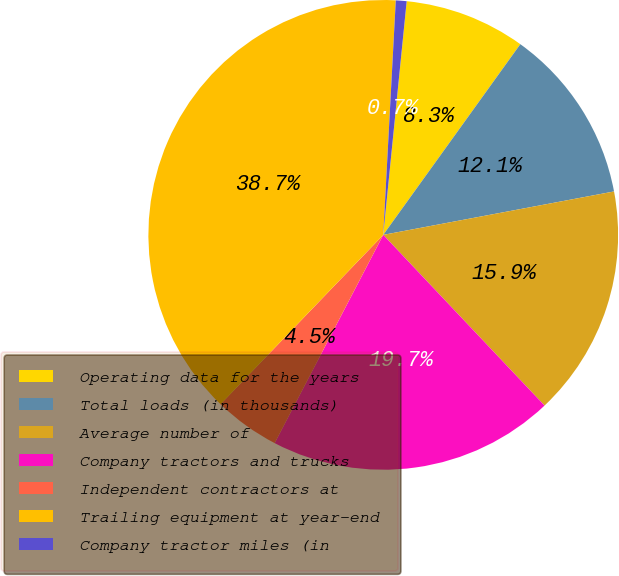Convert chart. <chart><loc_0><loc_0><loc_500><loc_500><pie_chart><fcel>Operating data for the years<fcel>Total loads (in thousands)<fcel>Average number of<fcel>Company tractors and trucks<fcel>Independent contractors at<fcel>Trailing equipment at year-end<fcel>Company tractor miles (in<nl><fcel>8.33%<fcel>12.12%<fcel>15.91%<fcel>19.7%<fcel>4.53%<fcel>38.67%<fcel>0.74%<nl></chart> 